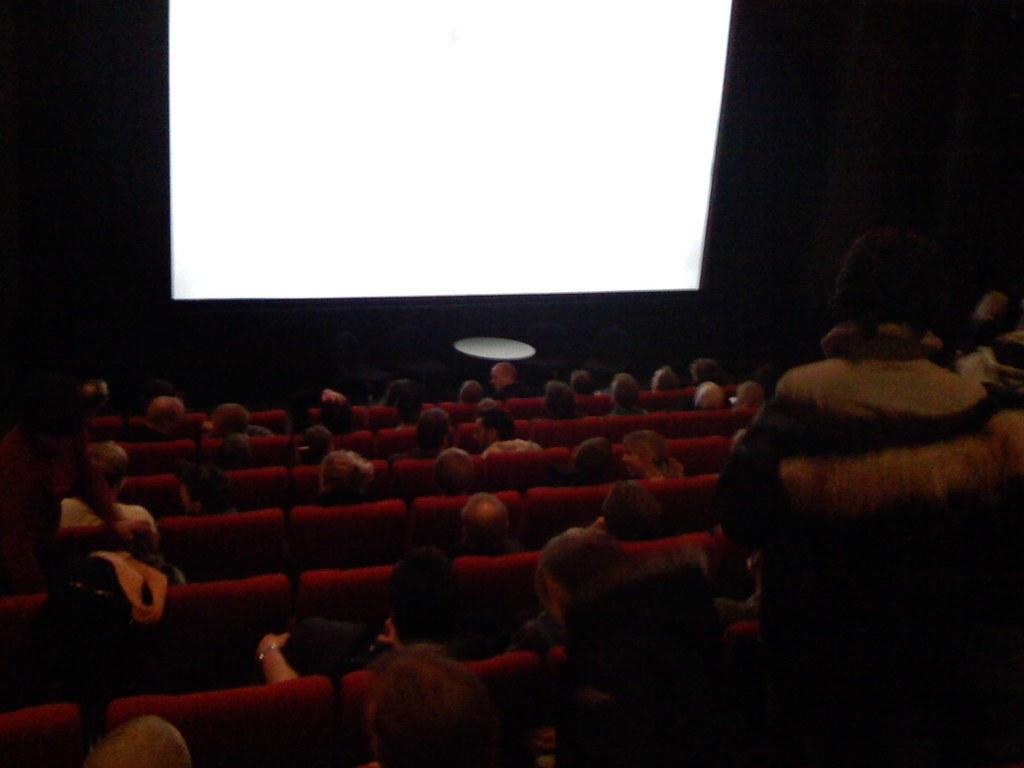In one or two sentences, can you explain what this image depicts? This picture is inside the theater. On the top we can see projector screen. On the bottom we can see group of persons sitting on the chair. On the right there is a man who is standing near to the chair. 